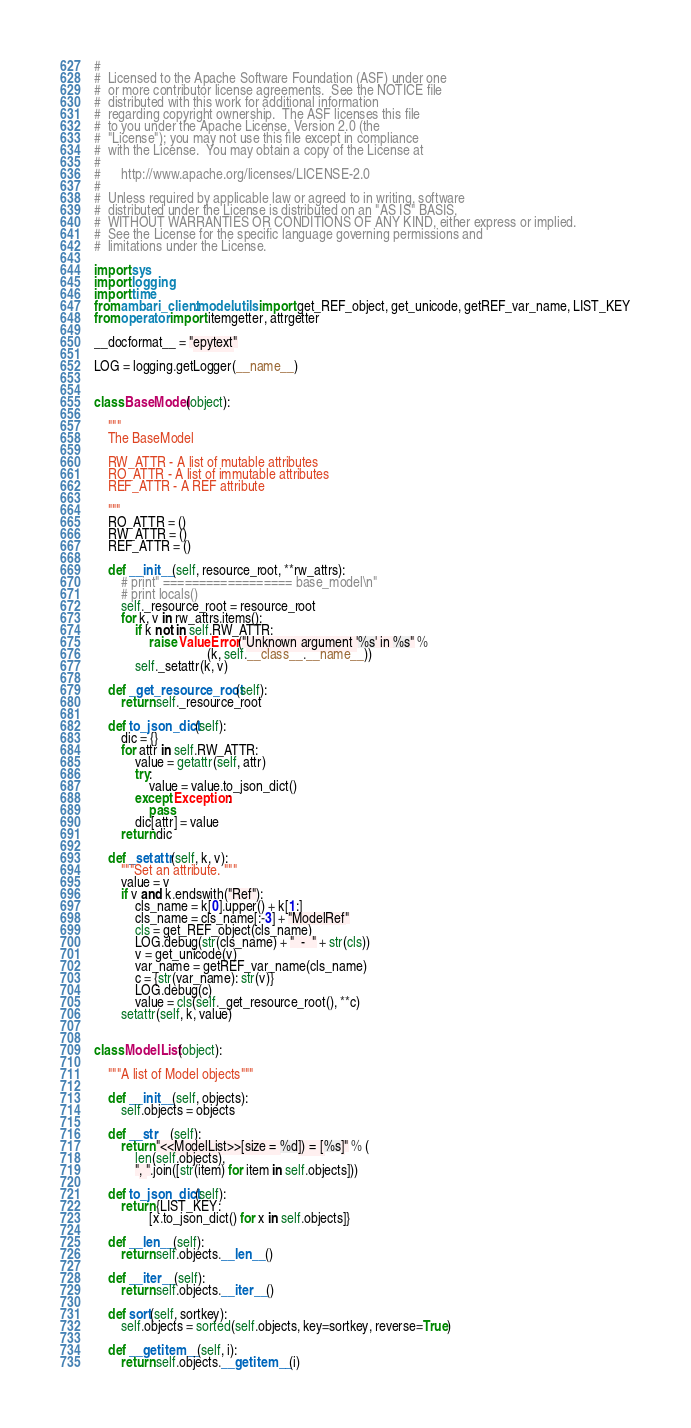<code> <loc_0><loc_0><loc_500><loc_500><_Python_>#
#  Licensed to the Apache Software Foundation (ASF) under one
#  or more contributor license agreements.  See the NOTICE file
#  distributed with this work for additional information
#  regarding copyright ownership.  The ASF licenses this file
#  to you under the Apache License, Version 2.0 (the
#  "License"); you may not use this file except in compliance
#  with the License.  You may obtain a copy of the License at
#
#      http://www.apache.org/licenses/LICENSE-2.0
#
#  Unless required by applicable law or agreed to in writing, software
#  distributed under the License is distributed on an "AS IS" BASIS,
#  WITHOUT WARRANTIES OR CONDITIONS OF ANY KIND, either express or implied.
#  See the License for the specific language governing permissions and
#  limitations under the License.

import sys
import logging
import time
from ambari_client.model.utils import get_REF_object, get_unicode, getREF_var_name, LIST_KEY
from operator import itemgetter, attrgetter

__docformat__ = "epytext"

LOG = logging.getLogger(__name__)


class BaseModel(object):

    """
    The BaseModel

    RW_ATTR - A list of mutable attributes
    RO_ATTR - A list of immutable attributes
    REF_ATTR - A REF attribute

    """
    RO_ATTR = ()
    RW_ATTR = ()
    REF_ATTR = ()

    def __init__(self, resource_root, **rw_attrs):
        # print" ================== base_model\n"
        # print locals()
        self._resource_root = resource_root
        for k, v in rw_attrs.items():
            if k not in self.RW_ATTR:
                raise ValueError("Unknown argument '%s' in %s" %
                                 (k, self.__class__.__name__))
            self._setattr(k, v)

    def _get_resource_root(self):
        return self._resource_root

    def to_json_dict(self):
        dic = {}
        for attr in self.RW_ATTR:
            value = getattr(self, attr)
            try:
                value = value.to_json_dict()
            except Exception:
                pass
            dic[attr] = value
        return dic

    def _setattr(self, k, v):
        """Set an attribute. """
        value = v
        if v and k.endswith("Ref"):
            cls_name = k[0].upper() + k[1:]
            cls_name = cls_name[:-3] + "ModelRef"
            cls = get_REF_object(cls_name)
            LOG.debug(str(cls_name) + "  -  " + str(cls))
            v = get_unicode(v)
            var_name = getREF_var_name(cls_name)
            c = {str(var_name): str(v)}
            LOG.debug(c)
            value = cls(self._get_resource_root(), **c)
        setattr(self, k, value)


class ModelList(object):

    """A list of Model objects"""

    def __init__(self, objects):
        self.objects = objects

    def __str__(self):
        return "<<ModelList>>[size = %d]) = [%s]" % (
            len(self.objects),
            ", ".join([str(item) for item in self.objects]))

    def to_json_dict(self):
        return {LIST_KEY:
                [x.to_json_dict() for x in self.objects]}

    def __len__(self):
        return self.objects.__len__()

    def __iter__(self):
        return self.objects.__iter__()

    def sort(self, sortkey):
        self.objects = sorted(self.objects, key=sortkey, reverse=True)

    def __getitem__(self, i):
        return self.objects.__getitem__(i)
</code> 